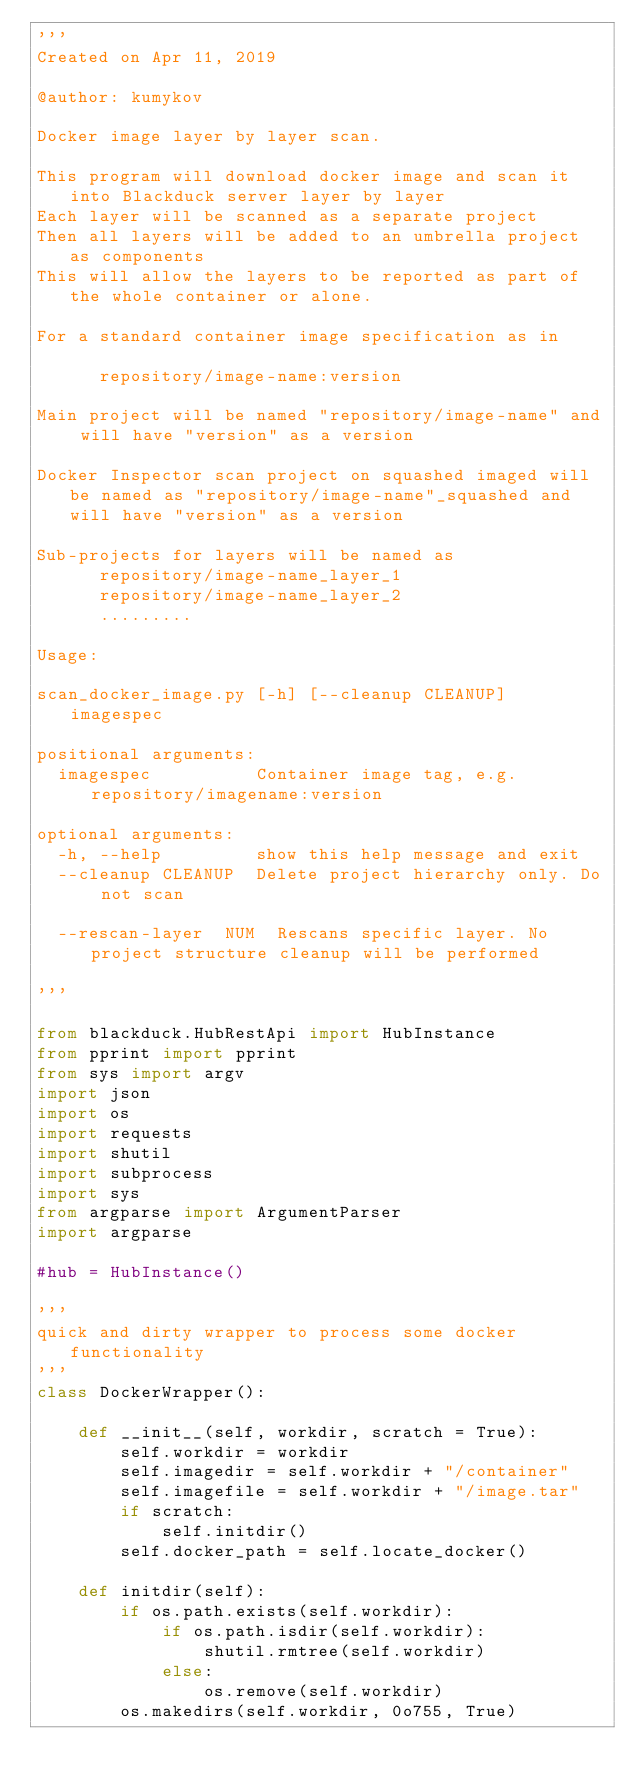Convert code to text. <code><loc_0><loc_0><loc_500><loc_500><_Python_>'''
Created on Apr 11, 2019

@author: kumykov

Docker image layer by layer scan.

This program will download docker image and scan it into Blackduck server layer by layer
Each layer will be scanned as a separate project
Then all layers will be added to an umbrella project as components
This will allow the layers to be reported as part of the whole container or alone.

For a standard container image specification as in

      repository/image-name:version

Main project will be named "repository/image-name" and will have "version" as a version

Docker Inspector scan project on squashed imaged will be named as "repository/image-name"_squashed and will have "version" as a version

Sub-projects for layers will be named as
      repository/image-name_layer_1
      repository/image-name_layer_2
      .........

Usage:

scan_docker_image.py [-h] [--cleanup CLEANUP] imagespec

positional arguments:
  imagespec          Container image tag, e.g. repository/imagename:version

optional arguments:
  -h, --help         show this help message and exit
  --cleanup CLEANUP  Delete project hierarchy only. Do not scan
  
  --rescan-layer  NUM  Rescans specific layer. No project structure cleanup will be performed

'''

from blackduck.HubRestApi import HubInstance
from pprint import pprint
from sys import argv
import json
import os
import requests
import shutil
import subprocess
import sys
from argparse import ArgumentParser
import argparse

#hub = HubInstance()

'''
quick and dirty wrapper to process some docker functionality
'''
class DockerWrapper():
   
    def __init__(self, workdir, scratch = True):
        self.workdir = workdir
        self.imagedir = self.workdir + "/container"
        self.imagefile = self.workdir + "/image.tar"
        if scratch:
            self.initdir()
        self.docker_path = self.locate_docker()
        
    def initdir(self):
        if os.path.exists(self.workdir):
            if os.path.isdir(self.workdir):
                shutil.rmtree(self.workdir)
            else:
                os.remove(self.workdir)
        os.makedirs(self.workdir, 0o755, True)</code> 